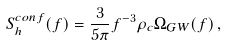Convert formula to latex. <formula><loc_0><loc_0><loc_500><loc_500>S ^ { c o n f } _ { h } ( f ) = \frac { 3 } { 5 \pi } f ^ { - 3 } \rho _ { c } \Omega _ { G W } ( f ) \, ,</formula> 